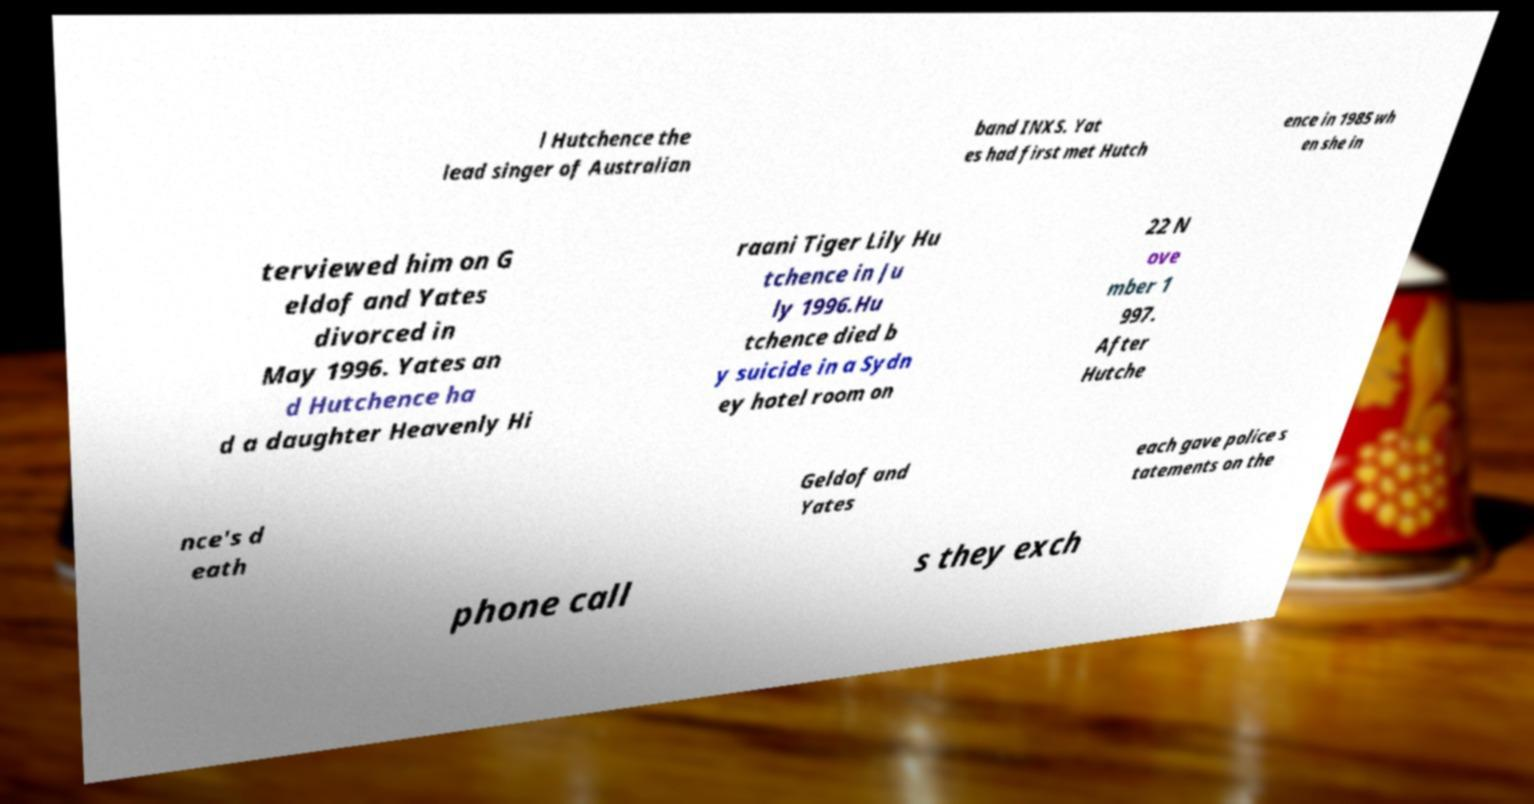I need the written content from this picture converted into text. Can you do that? l Hutchence the lead singer of Australian band INXS. Yat es had first met Hutch ence in 1985 wh en she in terviewed him on G eldof and Yates divorced in May 1996. Yates an d Hutchence ha d a daughter Heavenly Hi raani Tiger Lily Hu tchence in Ju ly 1996.Hu tchence died b y suicide in a Sydn ey hotel room on 22 N ove mber 1 997. After Hutche nce's d eath Geldof and Yates each gave police s tatements on the phone call s they exch 